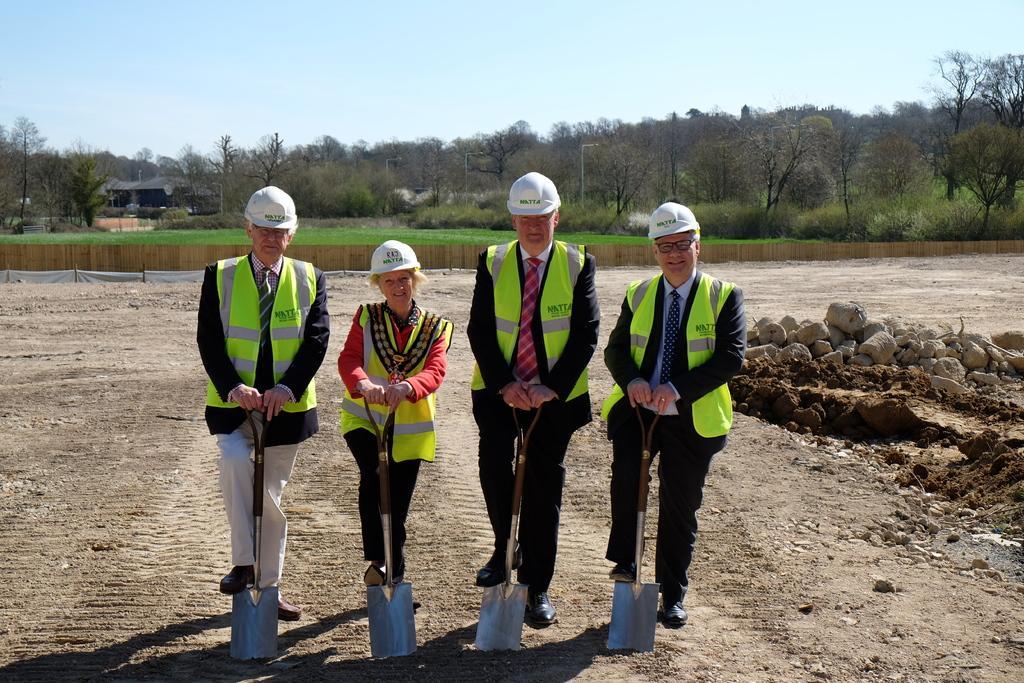Please provide a concise description of this image. In this picture we can see four persons are standing and holding shovels, they wore helmets, jackets and shoes, on the right side there are some stones, in the background we can see some trees, grass and a house, there is the sky at the top of the picture, we can see soil at the bottom. 